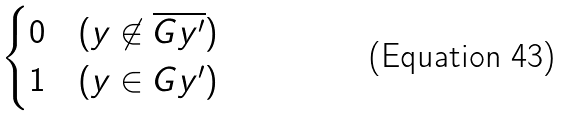<formula> <loc_0><loc_0><loc_500><loc_500>\begin{cases} 0 & ( y \not \in \overline { G y ^ { \prime } } ) \\ 1 & ( y \in G y ^ { \prime } ) \end{cases}</formula> 